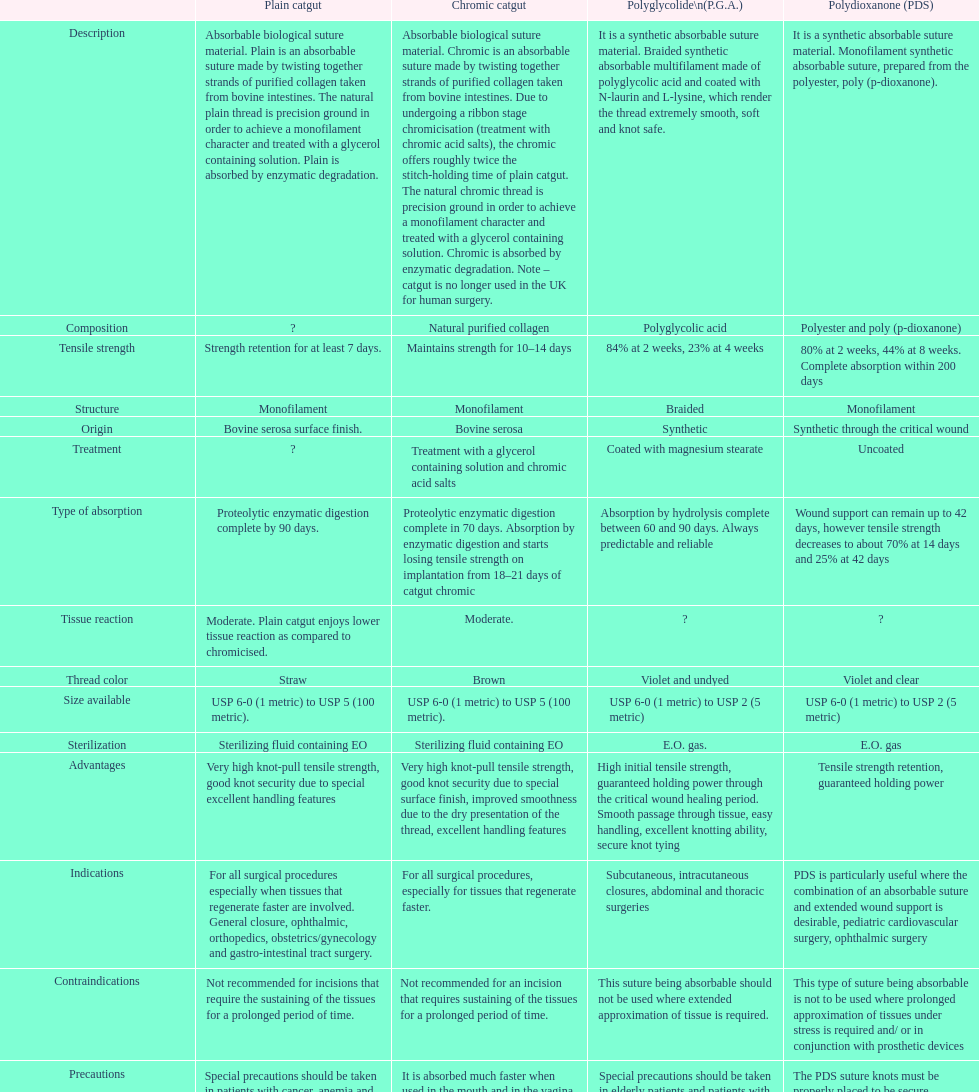What is the total number of suture materials that have a mono-filament structure? 3. 